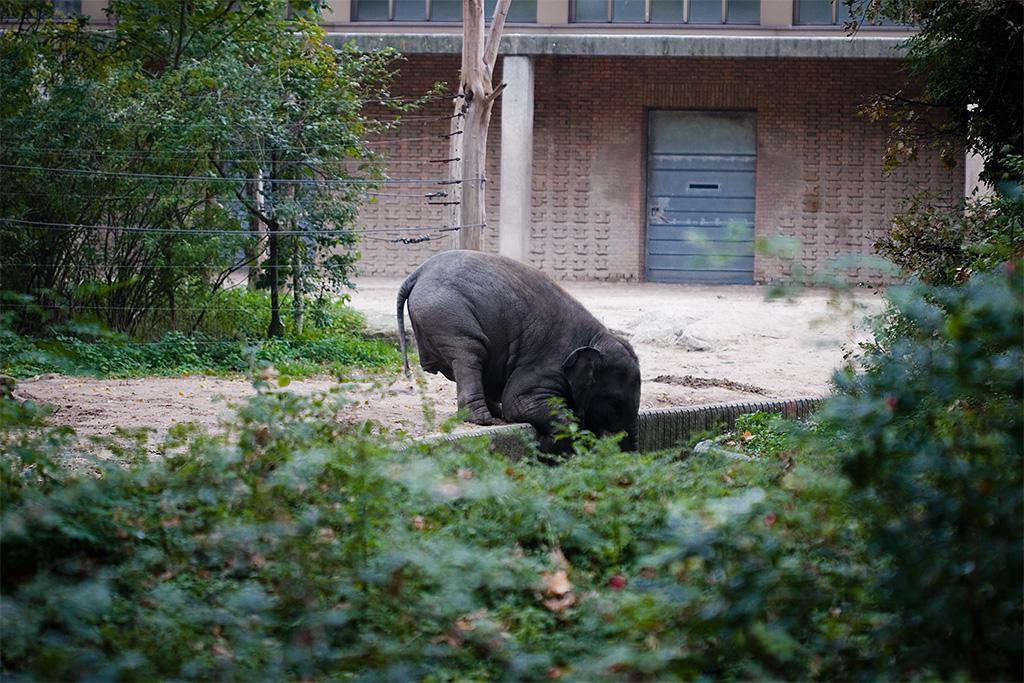Can you describe this image briefly? I the image i can see a animal,plants and the house. 